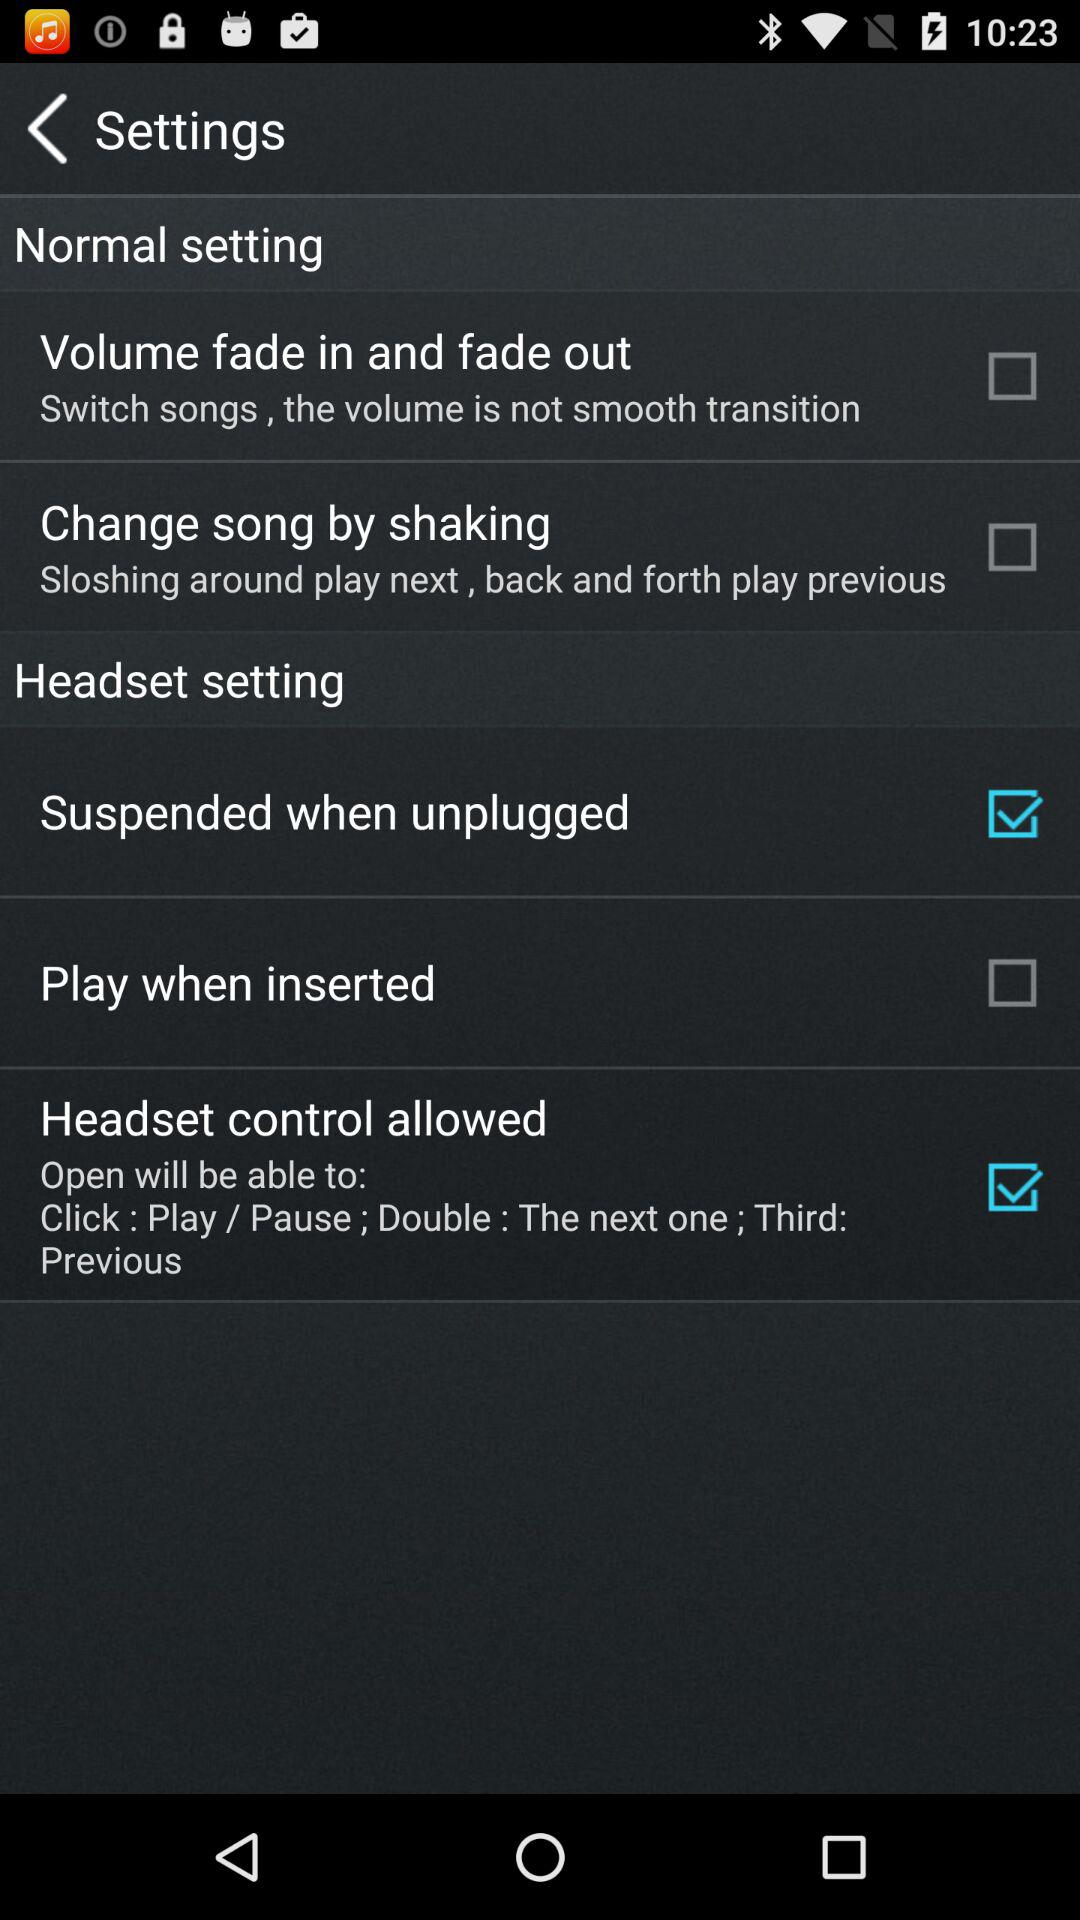How many settings are related to the headset?
Answer the question using a single word or phrase. 3 